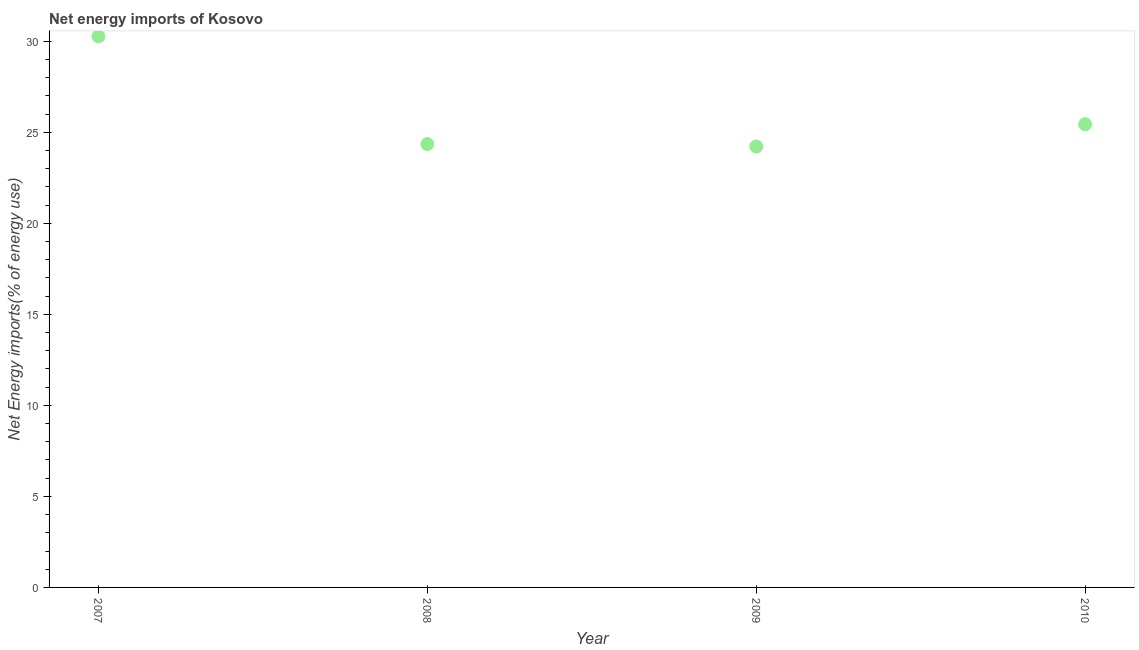What is the energy imports in 2010?
Make the answer very short. 25.44. Across all years, what is the maximum energy imports?
Offer a very short reply. 30.27. Across all years, what is the minimum energy imports?
Offer a very short reply. 24.21. In which year was the energy imports maximum?
Provide a succinct answer. 2007. In which year was the energy imports minimum?
Your answer should be very brief. 2009. What is the sum of the energy imports?
Give a very brief answer. 104.27. What is the difference between the energy imports in 2007 and 2010?
Offer a very short reply. 4.83. What is the average energy imports per year?
Offer a terse response. 26.07. What is the median energy imports?
Provide a succinct answer. 24.89. Do a majority of the years between 2009 and 2010 (inclusive) have energy imports greater than 14 %?
Offer a very short reply. Yes. What is the ratio of the energy imports in 2008 to that in 2009?
Provide a succinct answer. 1.01. Is the energy imports in 2007 less than that in 2010?
Offer a terse response. No. What is the difference between the highest and the second highest energy imports?
Offer a very short reply. 4.83. Is the sum of the energy imports in 2007 and 2009 greater than the maximum energy imports across all years?
Provide a succinct answer. Yes. What is the difference between the highest and the lowest energy imports?
Offer a very short reply. 6.05. How many dotlines are there?
Your answer should be compact. 1. How many years are there in the graph?
Offer a very short reply. 4. What is the title of the graph?
Ensure brevity in your answer.  Net energy imports of Kosovo. What is the label or title of the X-axis?
Give a very brief answer. Year. What is the label or title of the Y-axis?
Your answer should be very brief. Net Energy imports(% of energy use). What is the Net Energy imports(% of energy use) in 2007?
Your response must be concise. 30.27. What is the Net Energy imports(% of energy use) in 2008?
Your answer should be compact. 24.35. What is the Net Energy imports(% of energy use) in 2009?
Make the answer very short. 24.21. What is the Net Energy imports(% of energy use) in 2010?
Keep it short and to the point. 25.44. What is the difference between the Net Energy imports(% of energy use) in 2007 and 2008?
Keep it short and to the point. 5.91. What is the difference between the Net Energy imports(% of energy use) in 2007 and 2009?
Give a very brief answer. 6.05. What is the difference between the Net Energy imports(% of energy use) in 2007 and 2010?
Your response must be concise. 4.83. What is the difference between the Net Energy imports(% of energy use) in 2008 and 2009?
Your answer should be very brief. 0.14. What is the difference between the Net Energy imports(% of energy use) in 2008 and 2010?
Keep it short and to the point. -1.09. What is the difference between the Net Energy imports(% of energy use) in 2009 and 2010?
Provide a succinct answer. -1.22. What is the ratio of the Net Energy imports(% of energy use) in 2007 to that in 2008?
Make the answer very short. 1.24. What is the ratio of the Net Energy imports(% of energy use) in 2007 to that in 2010?
Keep it short and to the point. 1.19. 